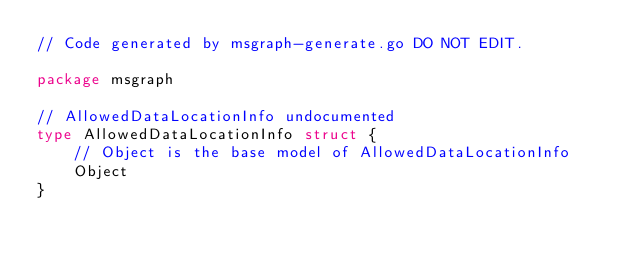<code> <loc_0><loc_0><loc_500><loc_500><_Go_>// Code generated by msgraph-generate.go DO NOT EDIT.

package msgraph

// AllowedDataLocationInfo undocumented
type AllowedDataLocationInfo struct {
	// Object is the base model of AllowedDataLocationInfo
	Object
}
</code> 